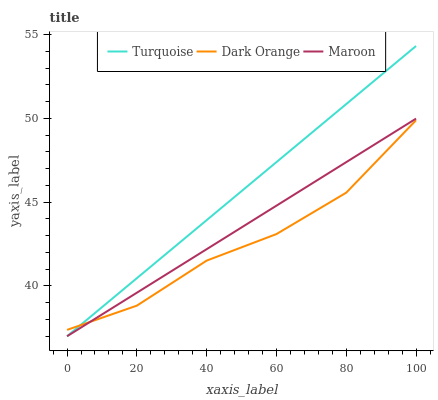Does Maroon have the minimum area under the curve?
Answer yes or no. No. Does Maroon have the maximum area under the curve?
Answer yes or no. No. Is Turquoise the smoothest?
Answer yes or no. No. Is Turquoise the roughest?
Answer yes or no. No. Does Maroon have the highest value?
Answer yes or no. No. 